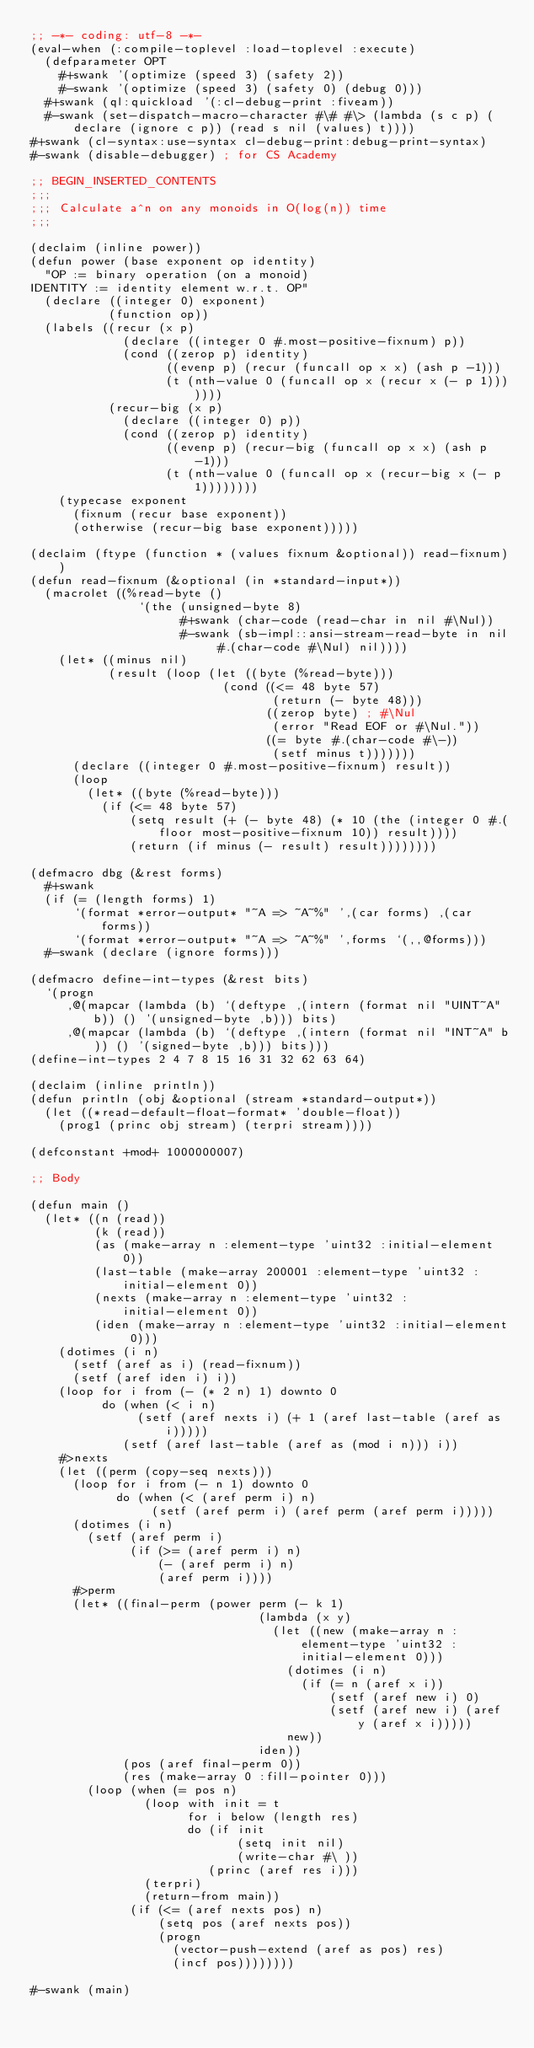<code> <loc_0><loc_0><loc_500><loc_500><_Lisp_>;; -*- coding: utf-8 -*-
(eval-when (:compile-toplevel :load-toplevel :execute)
  (defparameter OPT
    #+swank '(optimize (speed 3) (safety 2))
    #-swank '(optimize (speed 3) (safety 0) (debug 0)))
  #+swank (ql:quickload '(:cl-debug-print :fiveam))
  #-swank (set-dispatch-macro-character #\# #\> (lambda (s c p) (declare (ignore c p)) (read s nil (values) t))))
#+swank (cl-syntax:use-syntax cl-debug-print:debug-print-syntax)
#-swank (disable-debugger) ; for CS Academy

;; BEGIN_INSERTED_CONTENTS
;;;
;;; Calculate a^n on any monoids in O(log(n)) time
;;;

(declaim (inline power))
(defun power (base exponent op identity)
  "OP := binary operation (on a monoid)
IDENTITY := identity element w.r.t. OP"
  (declare ((integer 0) exponent)
           (function op))
  (labels ((recur (x p)
             (declare ((integer 0 #.most-positive-fixnum) p))
             (cond ((zerop p) identity)
                   ((evenp p) (recur (funcall op x x) (ash p -1)))
                   (t (nth-value 0 (funcall op x (recur x (- p 1)))))))
           (recur-big (x p)
             (declare ((integer 0) p))
             (cond ((zerop p) identity)
                   ((evenp p) (recur-big (funcall op x x) (ash p -1)))
                   (t (nth-value 0 (funcall op x (recur-big x (- p 1))))))))
    (typecase exponent
      (fixnum (recur base exponent))
      (otherwise (recur-big base exponent)))))

(declaim (ftype (function * (values fixnum &optional)) read-fixnum))
(defun read-fixnum (&optional (in *standard-input*))
  (macrolet ((%read-byte ()
               `(the (unsigned-byte 8)
                     #+swank (char-code (read-char in nil #\Nul))
                     #-swank (sb-impl::ansi-stream-read-byte in nil #.(char-code #\Nul) nil))))
    (let* ((minus nil)
           (result (loop (let ((byte (%read-byte)))
                           (cond ((<= 48 byte 57)
                                  (return (- byte 48)))
                                 ((zerop byte) ; #\Nul
                                  (error "Read EOF or #\Nul."))
                                 ((= byte #.(char-code #\-))
                                  (setf minus t)))))))
      (declare ((integer 0 #.most-positive-fixnum) result))
      (loop
        (let* ((byte (%read-byte)))
          (if (<= 48 byte 57)
              (setq result (+ (- byte 48) (* 10 (the (integer 0 #.(floor most-positive-fixnum 10)) result))))
              (return (if minus (- result) result))))))))

(defmacro dbg (&rest forms)
  #+swank
  (if (= (length forms) 1)
      `(format *error-output* "~A => ~A~%" ',(car forms) ,(car forms))
      `(format *error-output* "~A => ~A~%" ',forms `(,,@forms)))
  #-swank (declare (ignore forms)))

(defmacro define-int-types (&rest bits)
  `(progn
     ,@(mapcar (lambda (b) `(deftype ,(intern (format nil "UINT~A" b)) () '(unsigned-byte ,b))) bits)
     ,@(mapcar (lambda (b) `(deftype ,(intern (format nil "INT~A" b)) () '(signed-byte ,b))) bits)))
(define-int-types 2 4 7 8 15 16 31 32 62 63 64)

(declaim (inline println))
(defun println (obj &optional (stream *standard-output*))
  (let ((*read-default-float-format* 'double-float))
    (prog1 (princ obj stream) (terpri stream))))

(defconstant +mod+ 1000000007)

;; Body

(defun main ()
  (let* ((n (read))
         (k (read))
         (as (make-array n :element-type 'uint32 :initial-element 0))
         (last-table (make-array 200001 :element-type 'uint32 :initial-element 0))
         (nexts (make-array n :element-type 'uint32 :initial-element 0))
         (iden (make-array n :element-type 'uint32 :initial-element 0)))
    (dotimes (i n)
      (setf (aref as i) (read-fixnum))
      (setf (aref iden i) i))
    (loop for i from (- (* 2 n) 1) downto 0
          do (when (< i n)
               (setf (aref nexts i) (+ 1 (aref last-table (aref as i)))))
             (setf (aref last-table (aref as (mod i n))) i))
    #>nexts
    (let ((perm (copy-seq nexts)))
      (loop for i from (- n 1) downto 0
            do (when (< (aref perm i) n)
                 (setf (aref perm i) (aref perm (aref perm i)))))
      (dotimes (i n)
        (setf (aref perm i)
              (if (>= (aref perm i) n)
                  (- (aref perm i) n)
                  (aref perm i))))
      #>perm
      (let* ((final-perm (power perm (- k 1)
                                (lambda (x y)
                                  (let ((new (make-array n :element-type 'uint32 :initial-element 0)))
                                    (dotimes (i n)
                                      (if (= n (aref x i))
                                          (setf (aref new i) 0)
                                          (setf (aref new i) (aref y (aref x i)))))
                                    new))
                                iden))
             (pos (aref final-perm 0))
             (res (make-array 0 :fill-pointer 0)))
        (loop (when (= pos n)
                (loop with init = t
                      for i below (length res)
                      do (if init
                             (setq init nil)
                             (write-char #\ ))
                         (princ (aref res i)))
                (terpri)
                (return-from main))
              (if (<= (aref nexts pos) n)
                  (setq pos (aref nexts pos))
                  (progn
                    (vector-push-extend (aref as pos) res)
                    (incf pos))))))))

#-swank (main)
</code> 